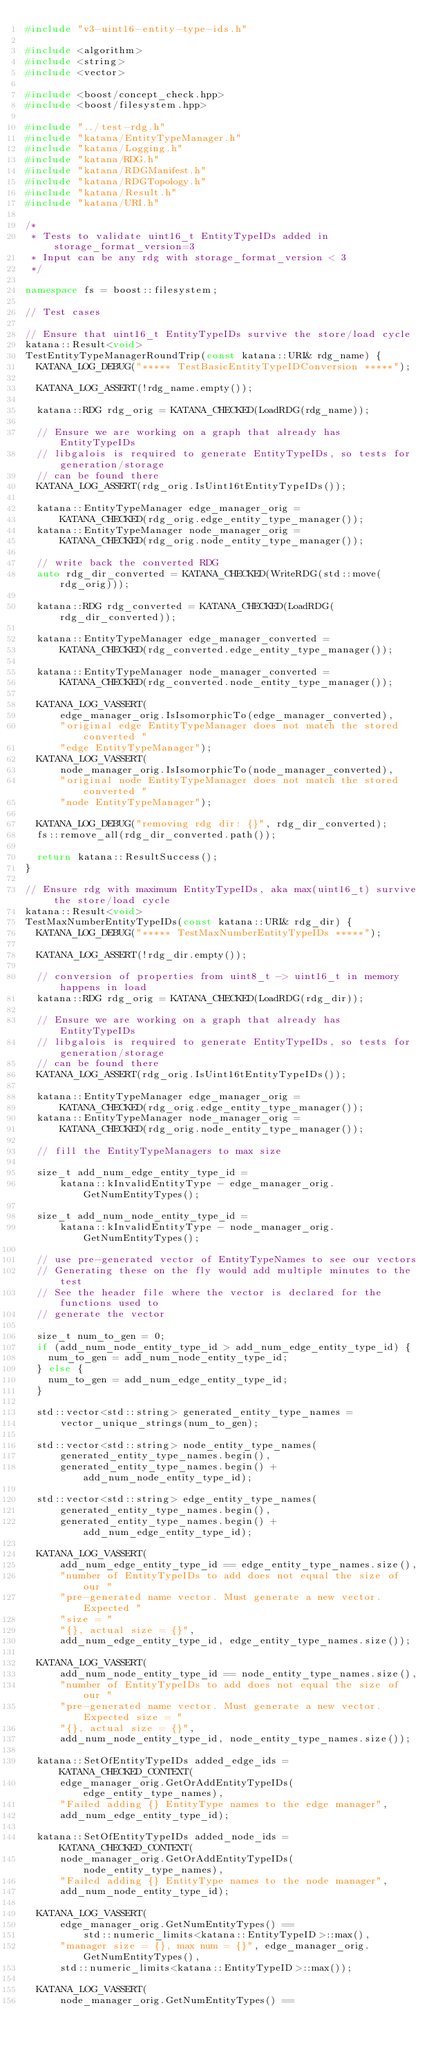Convert code to text. <code><loc_0><loc_0><loc_500><loc_500><_C++_>#include "v3-uint16-entity-type-ids.h"

#include <algorithm>
#include <string>
#include <vector>

#include <boost/concept_check.hpp>
#include <boost/filesystem.hpp>

#include "../test-rdg.h"
#include "katana/EntityTypeManager.h"
#include "katana/Logging.h"
#include "katana/RDG.h"
#include "katana/RDGManifest.h"
#include "katana/RDGTopology.h"
#include "katana/Result.h"
#include "katana/URI.h"

/*
 * Tests to validate uint16_t EntityTypeIDs added in storage_format_version=3
 * Input can be any rdg with storage_format_version < 3
 */

namespace fs = boost::filesystem;

// Test cases

// Ensure that uint16_t EntityTypeIDs survive the store/load cycle
katana::Result<void>
TestEntityTypeManagerRoundTrip(const katana::URI& rdg_name) {
  KATANA_LOG_DEBUG("***** TestBasicEntityTypeIDConversion *****");

  KATANA_LOG_ASSERT(!rdg_name.empty());

  katana::RDG rdg_orig = KATANA_CHECKED(LoadRDG(rdg_name));

  // Ensure we are working on a graph that already has EntityTypeIDs
  // libgalois is required to generate EntityTypeIDs, so tests for generation/storage
  // can be found there
  KATANA_LOG_ASSERT(rdg_orig.IsUint16tEntityTypeIDs());

  katana::EntityTypeManager edge_manager_orig =
      KATANA_CHECKED(rdg_orig.edge_entity_type_manager());
  katana::EntityTypeManager node_manager_orig =
      KATANA_CHECKED(rdg_orig.node_entity_type_manager());

  // write back the converted RDG
  auto rdg_dir_converted = KATANA_CHECKED(WriteRDG(std::move(rdg_orig)));

  katana::RDG rdg_converted = KATANA_CHECKED(LoadRDG(rdg_dir_converted));

  katana::EntityTypeManager edge_manager_converted =
      KATANA_CHECKED(rdg_converted.edge_entity_type_manager());

  katana::EntityTypeManager node_manager_converted =
      KATANA_CHECKED(rdg_converted.node_entity_type_manager());

  KATANA_LOG_VASSERT(
      edge_manager_orig.IsIsomorphicTo(edge_manager_converted),
      "original edge EntityTypeManager does not match the stored converted "
      "edge EntityTypeManager");
  KATANA_LOG_VASSERT(
      node_manager_orig.IsIsomorphicTo(node_manager_converted),
      "original node EntityTypeManager does not match the stored converted "
      "node EntityTypeManager");

  KATANA_LOG_DEBUG("removing rdg dir: {}", rdg_dir_converted);
  fs::remove_all(rdg_dir_converted.path());

  return katana::ResultSuccess();
}

// Ensure rdg with maximum EntityTypeIDs, aka max(uint16_t) survive the store/load cycle
katana::Result<void>
TestMaxNumberEntityTypeIDs(const katana::URI& rdg_dir) {
  KATANA_LOG_DEBUG("***** TestMaxNumberEntityTypeIDs *****");

  KATANA_LOG_ASSERT(!rdg_dir.empty());

  // conversion of properties from uint8_t -> uint16_t in memory happens in load
  katana::RDG rdg_orig = KATANA_CHECKED(LoadRDG(rdg_dir));

  // Ensure we are working on a graph that already has EntityTypeIDs
  // libgalois is required to generate EntityTypeIDs, so tests for generation/storage
  // can be found there
  KATANA_LOG_ASSERT(rdg_orig.IsUint16tEntityTypeIDs());

  katana::EntityTypeManager edge_manager_orig =
      KATANA_CHECKED(rdg_orig.edge_entity_type_manager());
  katana::EntityTypeManager node_manager_orig =
      KATANA_CHECKED(rdg_orig.node_entity_type_manager());

  // fill the EntityTypeManagers to max size

  size_t add_num_edge_entity_type_id =
      katana::kInvalidEntityType - edge_manager_orig.GetNumEntityTypes();

  size_t add_num_node_entity_type_id =
      katana::kInvalidEntityType - node_manager_orig.GetNumEntityTypes();

  // use pre-generated vector of EntityTypeNames to see our vectors
  // Generating these on the fly would add multiple minutes to the test
  // See the header file where the vector is declared for the functions used to
  // generate the vector

  size_t num_to_gen = 0;
  if (add_num_node_entity_type_id > add_num_edge_entity_type_id) {
    num_to_gen = add_num_node_entity_type_id;
  } else {
    num_to_gen = add_num_edge_entity_type_id;
  }

  std::vector<std::string> generated_entity_type_names =
      vector_unique_strings(num_to_gen);

  std::vector<std::string> node_entity_type_names(
      generated_entity_type_names.begin(),
      generated_entity_type_names.begin() + add_num_node_entity_type_id);

  std::vector<std::string> edge_entity_type_names(
      generated_entity_type_names.begin(),
      generated_entity_type_names.begin() + add_num_edge_entity_type_id);

  KATANA_LOG_VASSERT(
      add_num_edge_entity_type_id == edge_entity_type_names.size(),
      "number of EntityTypeIDs to add does not equal the size of our "
      "pre-generated name vector. Must generate a new vector. Expected "
      "size = "
      "{}, actual size = {}",
      add_num_edge_entity_type_id, edge_entity_type_names.size());

  KATANA_LOG_VASSERT(
      add_num_node_entity_type_id == node_entity_type_names.size(),
      "number of EntityTypeIDs to add does not equal the size of our "
      "pre-generated name vector. Must generate a new vector. Expected size = "
      "{}, actual size = {}",
      add_num_node_entity_type_id, node_entity_type_names.size());

  katana::SetOfEntityTypeIDs added_edge_ids = KATANA_CHECKED_CONTEXT(
      edge_manager_orig.GetOrAddEntityTypeIDs(edge_entity_type_names),
      "Failed adding {} EntityType names to the edge manager",
      add_num_edge_entity_type_id);

  katana::SetOfEntityTypeIDs added_node_ids = KATANA_CHECKED_CONTEXT(
      node_manager_orig.GetOrAddEntityTypeIDs(node_entity_type_names),
      "Failed adding {} EntityType names to the node manager",
      add_num_node_entity_type_id);

  KATANA_LOG_VASSERT(
      edge_manager_orig.GetNumEntityTypes() ==
          std::numeric_limits<katana::EntityTypeID>::max(),
      "manager size = {}, max num = {}", edge_manager_orig.GetNumEntityTypes(),
      std::numeric_limits<katana::EntityTypeID>::max());

  KATANA_LOG_VASSERT(
      node_manager_orig.GetNumEntityTypes() ==</code> 